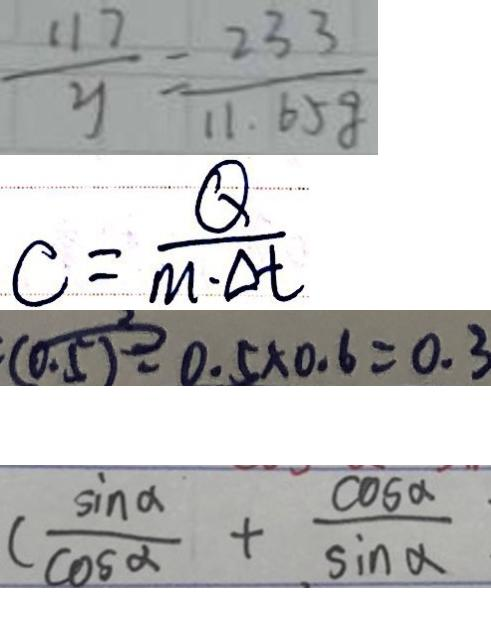Convert formula to latex. <formula><loc_0><loc_0><loc_500><loc_500>\frac { 1 1 7 } { y } = \frac { 2 3 3 } { 1 1 . 6 5 g } 
 c = \frac { Q } { m \cdot \Delta t } 
 0 . 5 \times 0 . 6 = 0 . 3 
 ( \frac { \sin \alpha } { \cos \alpha } + \frac { \cos \alpha } { \sin \alpha }</formula> 